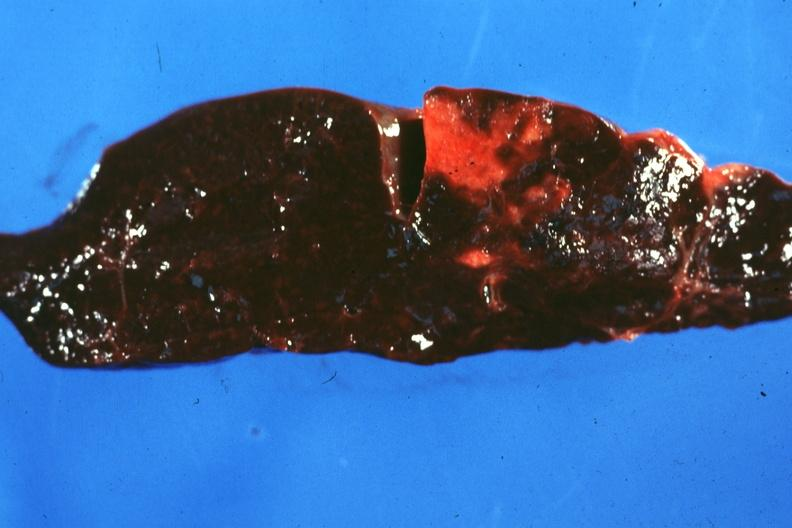s infarct present?
Answer the question using a single word or phrase. Yes 